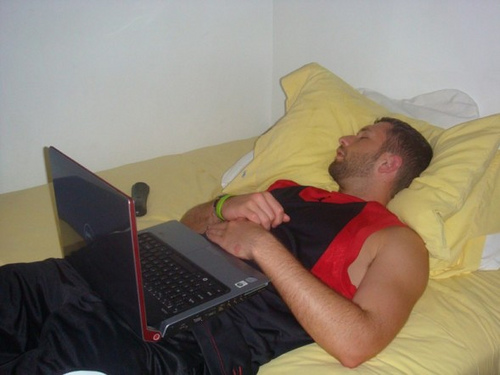What might the person be dreaming about right now? Perhaps he's dreaming of winning a crucial game for his college team, the roar of the crowd ringing in his ears as he scores the final point. Or maybe he's envisioning an idyllic vacation, lying on a sunny beach with the sound of waves soothing his mind, a stark contrast to his current reality. He could also be dreaming about solving a complex problem for his project, the satisfaction of intellectual triumph lighting up his subconscious. The serene expression on his face suggests a peaceful and pleasant dream, a brief escape from the demands of daily life. 